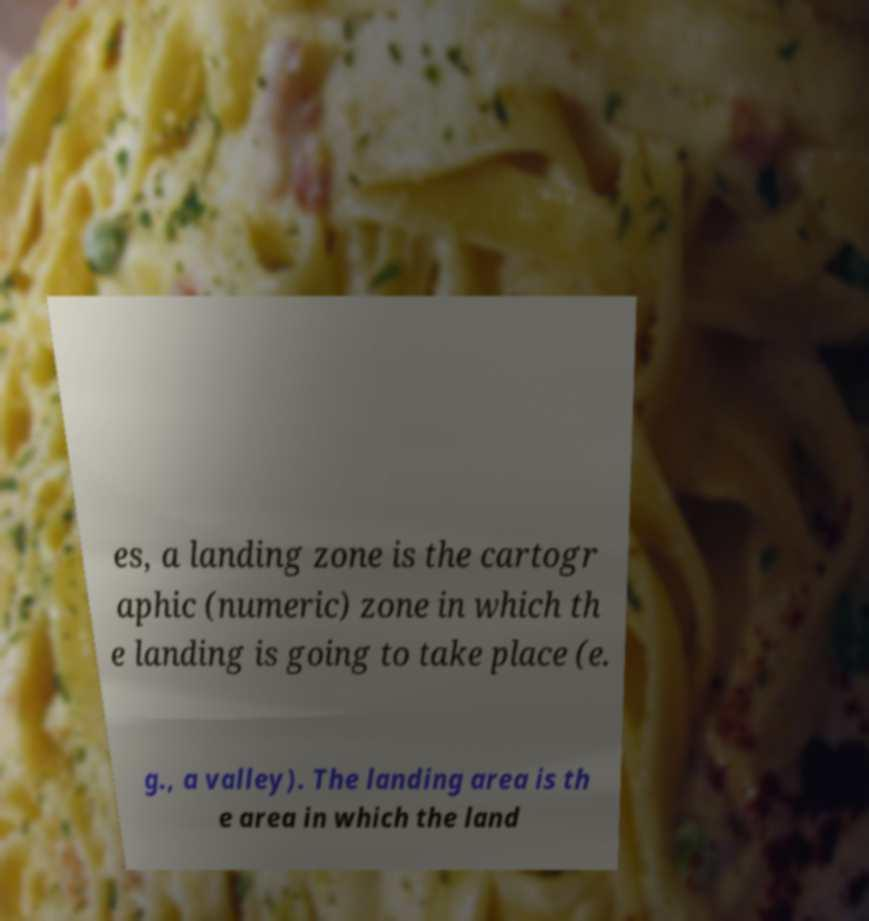Please read and relay the text visible in this image. What does it say? es, a landing zone is the cartogr aphic (numeric) zone in which th e landing is going to take place (e. g., a valley). The landing area is th e area in which the land 